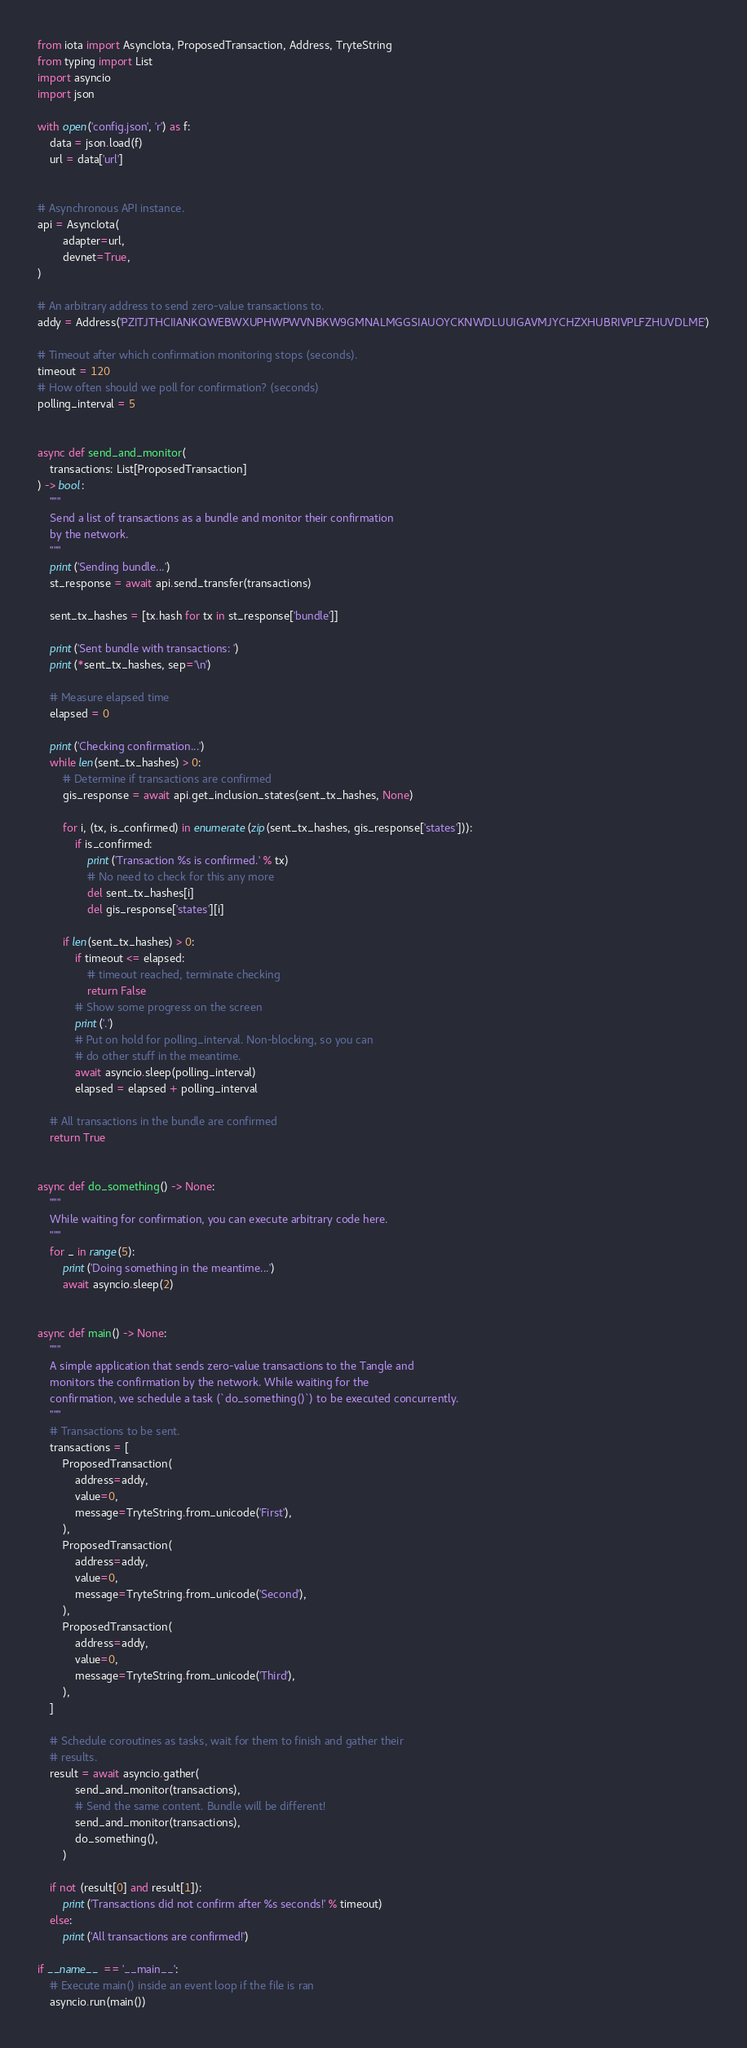<code> <loc_0><loc_0><loc_500><loc_500><_Python_>from iota import AsyncIota, ProposedTransaction, Address, TryteString
from typing import List
import asyncio
import json

with open('config.json', 'r') as f:
    data = json.load(f)
    url = data['url']


# Asynchronous API instance.
api = AsyncIota(
        adapter=url,
        devnet=True,
)

# An arbitrary address to send zero-value transactions to.
addy = Address('PZITJTHCIIANKQWEBWXUPHWPWVNBKW9GMNALMGGSIAUOYCKNWDLUUIGAVMJYCHZXHUBRIVPLFZHUVDLME')

# Timeout after which confirmation monitoring stops (seconds).
timeout = 120
# How often should we poll for confirmation? (seconds)
polling_interval = 5


async def send_and_monitor(
    transactions: List[ProposedTransaction]
) -> bool:
    """
    Send a list of transactions as a bundle and monitor their confirmation
    by the network.
    """
    print('Sending bundle...')
    st_response = await api.send_transfer(transactions)

    sent_tx_hashes = [tx.hash for tx in st_response['bundle']]

    print('Sent bundle with transactions: ')
    print(*sent_tx_hashes, sep='\n')

    # Measure elapsed time
    elapsed = 0

    print('Checking confirmation...')
    while len(sent_tx_hashes) > 0:
        # Determine if transactions are confirmed
        gis_response = await api.get_inclusion_states(sent_tx_hashes, None)

        for i, (tx, is_confirmed) in enumerate(zip(sent_tx_hashes, gis_response['states'])):
            if is_confirmed:
                print('Transaction %s is confirmed.' % tx)
                # No need to check for this any more
                del sent_tx_hashes[i]
                del gis_response['states'][i]

        if len(sent_tx_hashes) > 0:
            if timeout <= elapsed:
                # timeout reached, terminate checking
                return False
            # Show some progress on the screen
            print('.')
            # Put on hold for polling_interval. Non-blocking, so you can
            # do other stuff in the meantime.
            await asyncio.sleep(polling_interval)
            elapsed = elapsed + polling_interval

    # All transactions in the bundle are confirmed
    return True


async def do_something() -> None:
    """
    While waiting for confirmation, you can execute arbitrary code here.
    """
    for _ in range(5):
        print('Doing something in the meantime...')
        await asyncio.sleep(2)


async def main() -> None:
    """
    A simple application that sends zero-value transactions to the Tangle and
    monitors the confirmation by the network. While waiting for the
    confirmation, we schedule a task (`do_something()`) to be executed concurrently.
    """
    # Transactions to be sent.
    transactions = [
        ProposedTransaction(
            address=addy,
            value=0,
            message=TryteString.from_unicode('First'),
        ),
        ProposedTransaction(
            address=addy,
            value=0,
            message=TryteString.from_unicode('Second'),
        ),
        ProposedTransaction(
            address=addy,
            value=0,
            message=TryteString.from_unicode('Third'),
        ),
    ]

    # Schedule coroutines as tasks, wait for them to finish and gather their
    # results.
    result = await asyncio.gather(
            send_and_monitor(transactions),
            # Send the same content. Bundle will be different!
            send_and_monitor(transactions),
            do_something(),
        )

    if not (result[0] and result[1]):
        print('Transactions did not confirm after %s seconds!' % timeout)
    else:
        print('All transactions are confirmed!')

if __name__ == '__main__':
    # Execute main() inside an event loop if the file is ran
    asyncio.run(main())</code> 